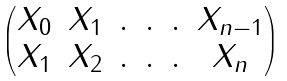Convert formula to latex. <formula><loc_0><loc_0><loc_500><loc_500>\begin{pmatrix} X _ { 0 } & X _ { 1 } & . & . & . & X _ { n - 1 } \\ X _ { 1 } & X _ { 2 } & . & . & . & X _ { n } \end{pmatrix}</formula> 